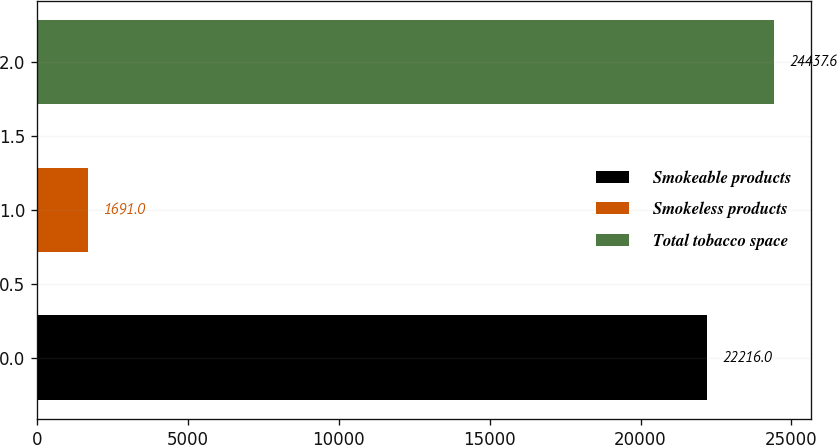Convert chart. <chart><loc_0><loc_0><loc_500><loc_500><bar_chart><fcel>Smokeable products<fcel>Smokeless products<fcel>Total tobacco space<nl><fcel>22216<fcel>1691<fcel>24437.6<nl></chart> 